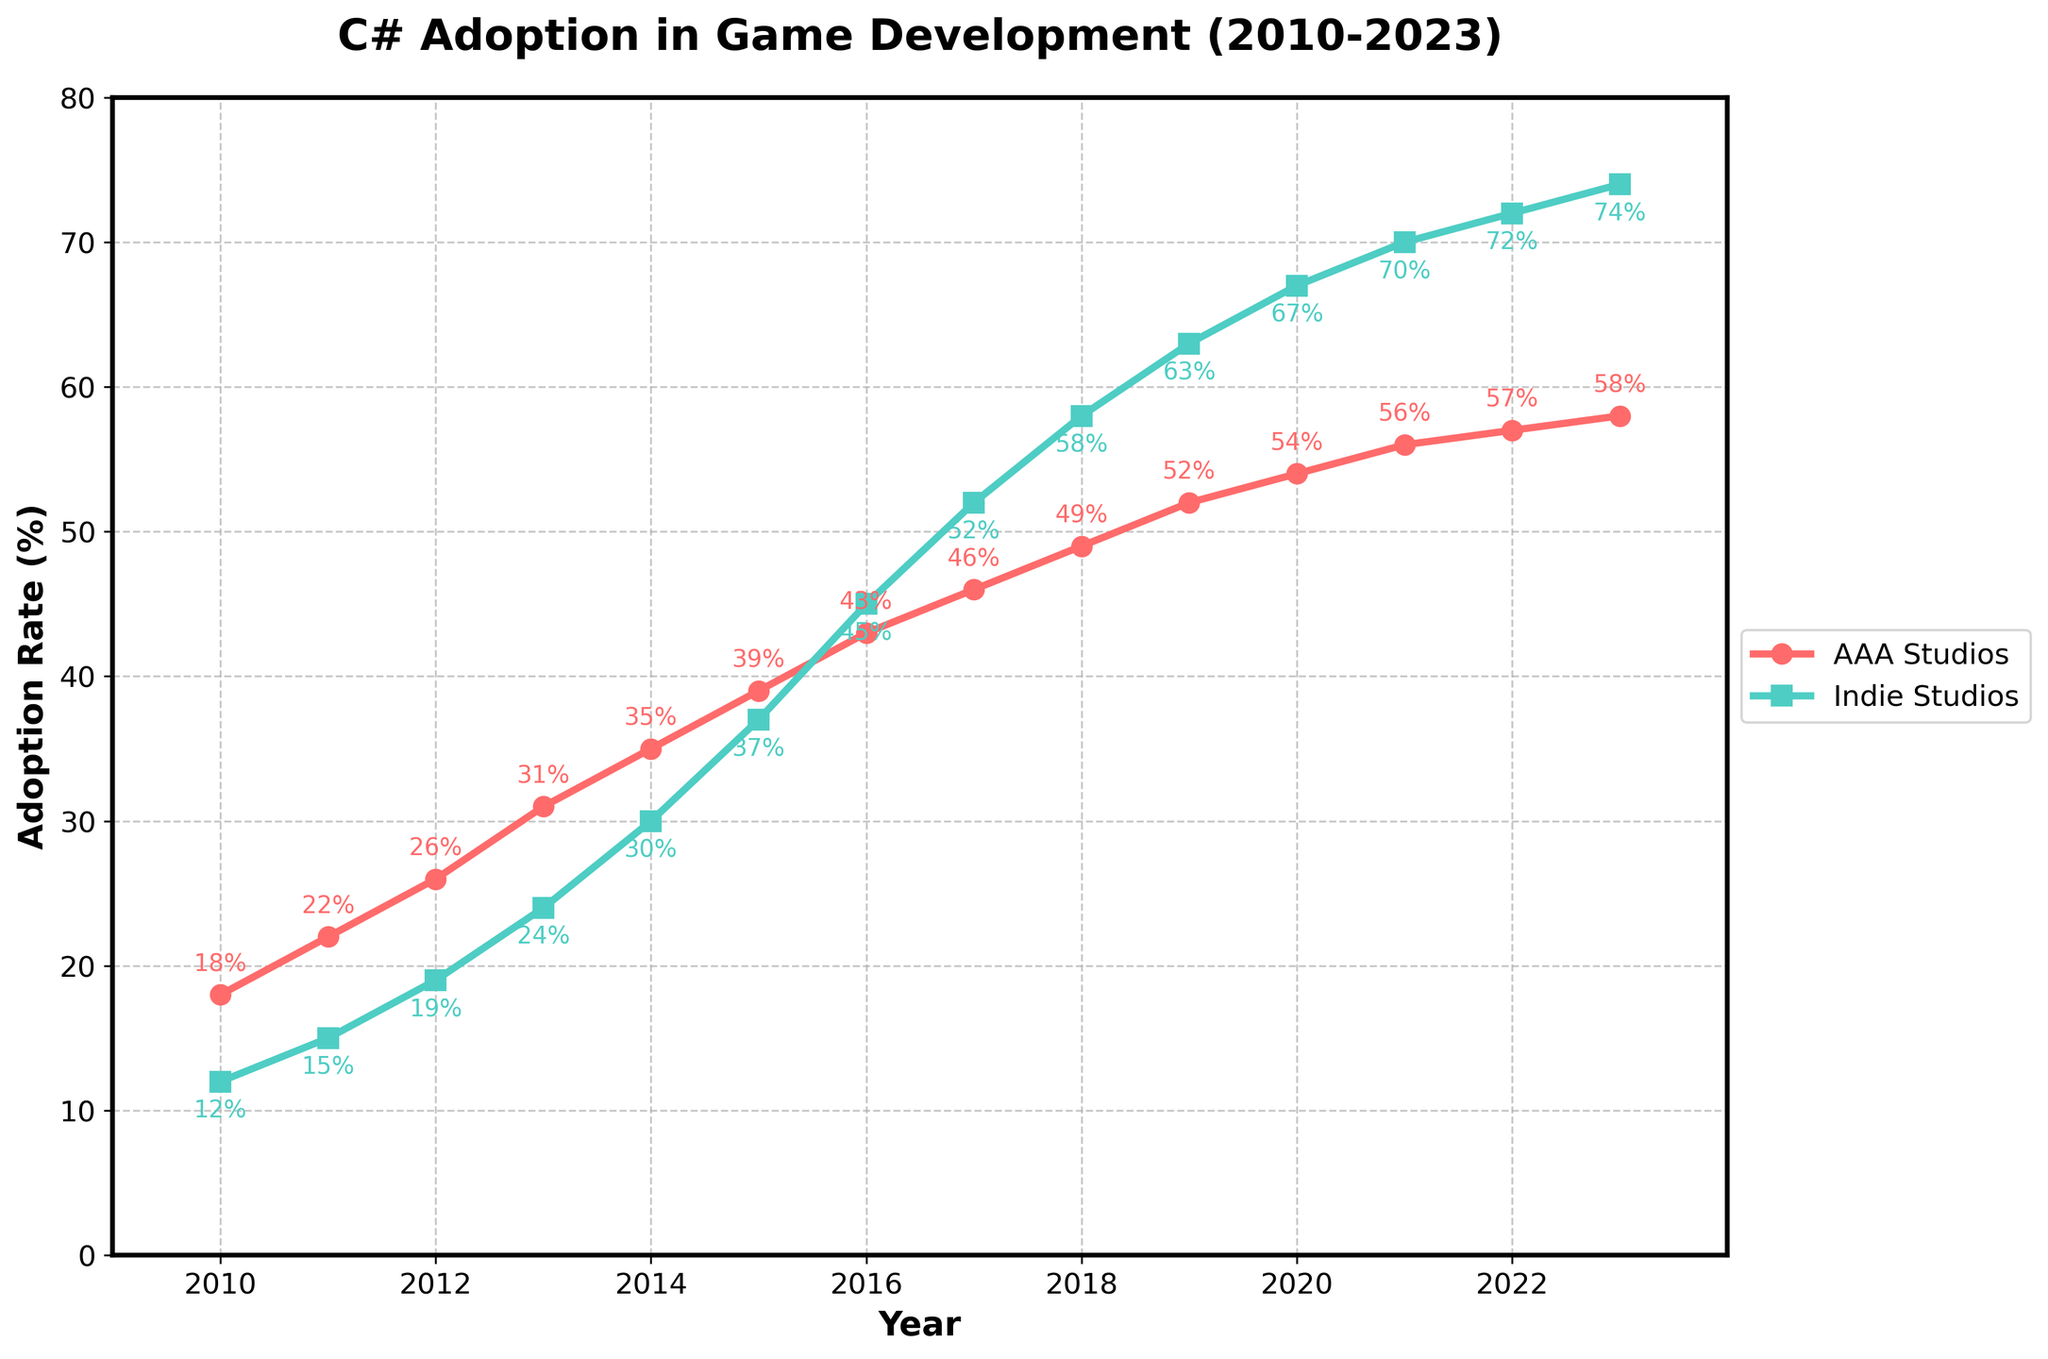what is the adoption rate difference between AAA and Indie Studios in 2010? To calculate the difference, subtract the adoption rate of Indie Studios from AAA Studios for the year 2010. According to the data, AAA Studios have an adoption rate of 18% and Indie Studios have 12%. Therefore, the difference is 18% - 12% = 6%.
Answer: 6% which year shows the highest adoption rate for Indie Studios? By looking at the chart, you can see that the highest point on the line representing Indie Studios is in the year 2023, with an adoption rate of 74%.
Answer: 2023 how does the adoption rate of AAA Studios in 2015 compare to that of Indie Studios in the same year? In 2015, the adoption rate for AAA Studios is 39% and for Indie Studios, it is 37%. Therefore, the rate for AAA Studios is slightly higher by 2 percentage points.
Answer: 2% in which year did the adoption rate for Indie Studios surpass that of AAA Studios? To determine this, examine the plot where the Indie Studios line crosses the AAA Studios line. This happens between 2015 and 2016. The data confirms that in 2016, Indie Studios had an adoption rate of 45%, surpassing AAA Studios at 43%.
Answer: 2016 what is the average adoption rate of Indie Studios over the period 2010-2023? To find the average, sum all adoption rates for Indie Studios from 2010 to 2023, and then divide by the number of years. The sum is 12+15+19+24+30+37+45+52+58+63+67+70+72+74 = 638. Since there are 14 data points, the average is 638/14 ≈ 45.57%.
Answer: 45.57% between 2010 and 2023, which type of studio saw a larger overall increase in adoption rate, and by how much? Calculate the overall increase for both AAA and Indie Studios. For AAA Studios: 58% (2023) - 18% (2010) = 40%. For Indie Studios: 74% (2023) - 12% (2010) = 62%. Indie Studios saw a larger increase by 62% - 40% = 22%.
Answer: Indie Studios, 22% In 2020, what is the combined adoption rate percentage for both AAA and Indie Studios? To find the combined adoption rate, sum the individual adoption rates for AAA and Indie Studios in 2020. The rates are 54% for AAA and 67% for Indie Studios, so the combined rate is 54% + 67% = 121%.
Answer: 121% during which consecutive years did AAA Studios see the highest increase in adoption rate? Analyzing year-over-year changes, find the highest increment for AAA Studios. The increase from 2013 (31%) to 2014 (35%) is 4%, from 2011 (22%) to 2012 (26%) is also 4%, but from 2012 to 2013 it's 5%. Therefore, the greatest increase occurred from 2012 to 2013 (31% - 26% = 5%).
Answer: 2012 to 2013 what is the difference in adoption rates between AAA Studios and Indie Studios in the final year of the data? In 2023, the adoption rate for AAA Studios is 58%, and for Indie Studios, it is 74%. The difference is 74% - 58% = 16%.
Answer: 16% 